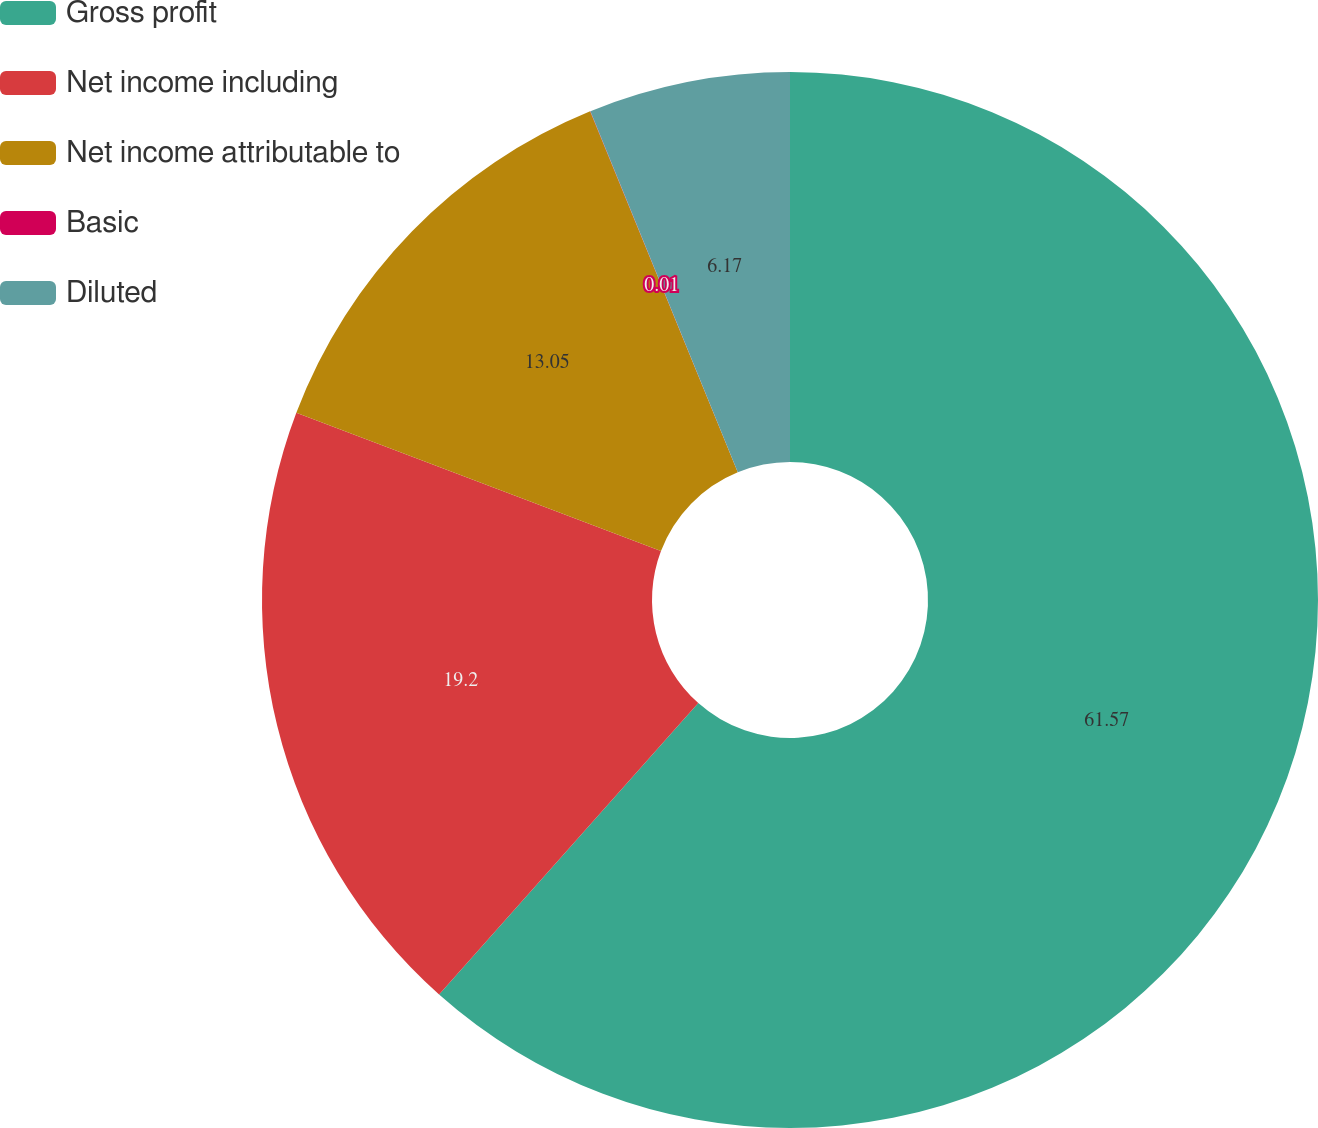<chart> <loc_0><loc_0><loc_500><loc_500><pie_chart><fcel>Gross profit<fcel>Net income including<fcel>Net income attributable to<fcel>Basic<fcel>Diluted<nl><fcel>61.57%<fcel>19.2%<fcel>13.05%<fcel>0.01%<fcel>6.17%<nl></chart> 